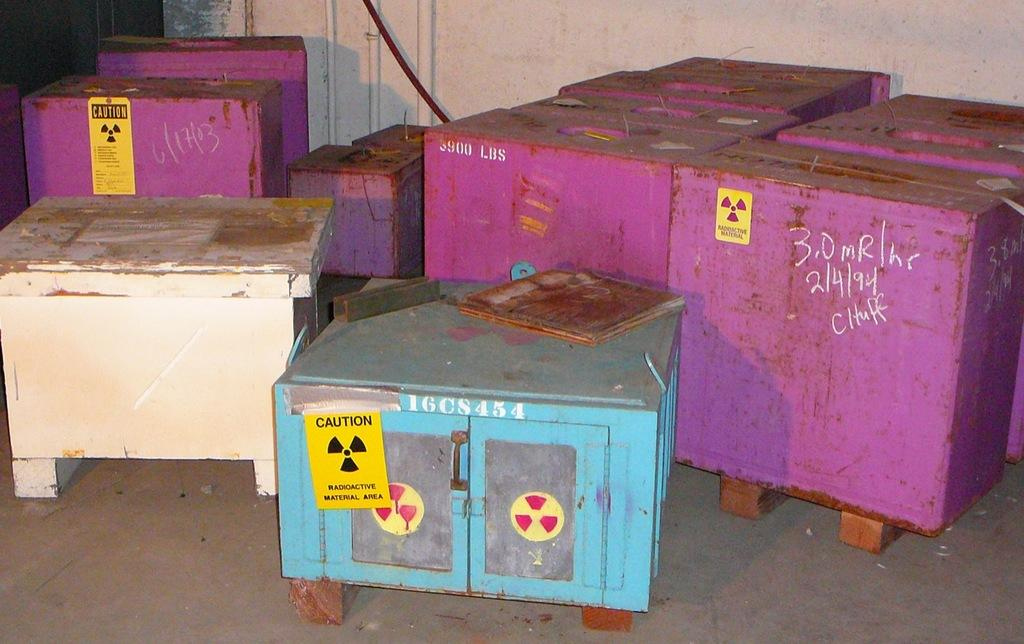Provide a one-sentence caption for the provided image. Pink, white and blue containers of radioactive material are stored in a radioactive material area. 